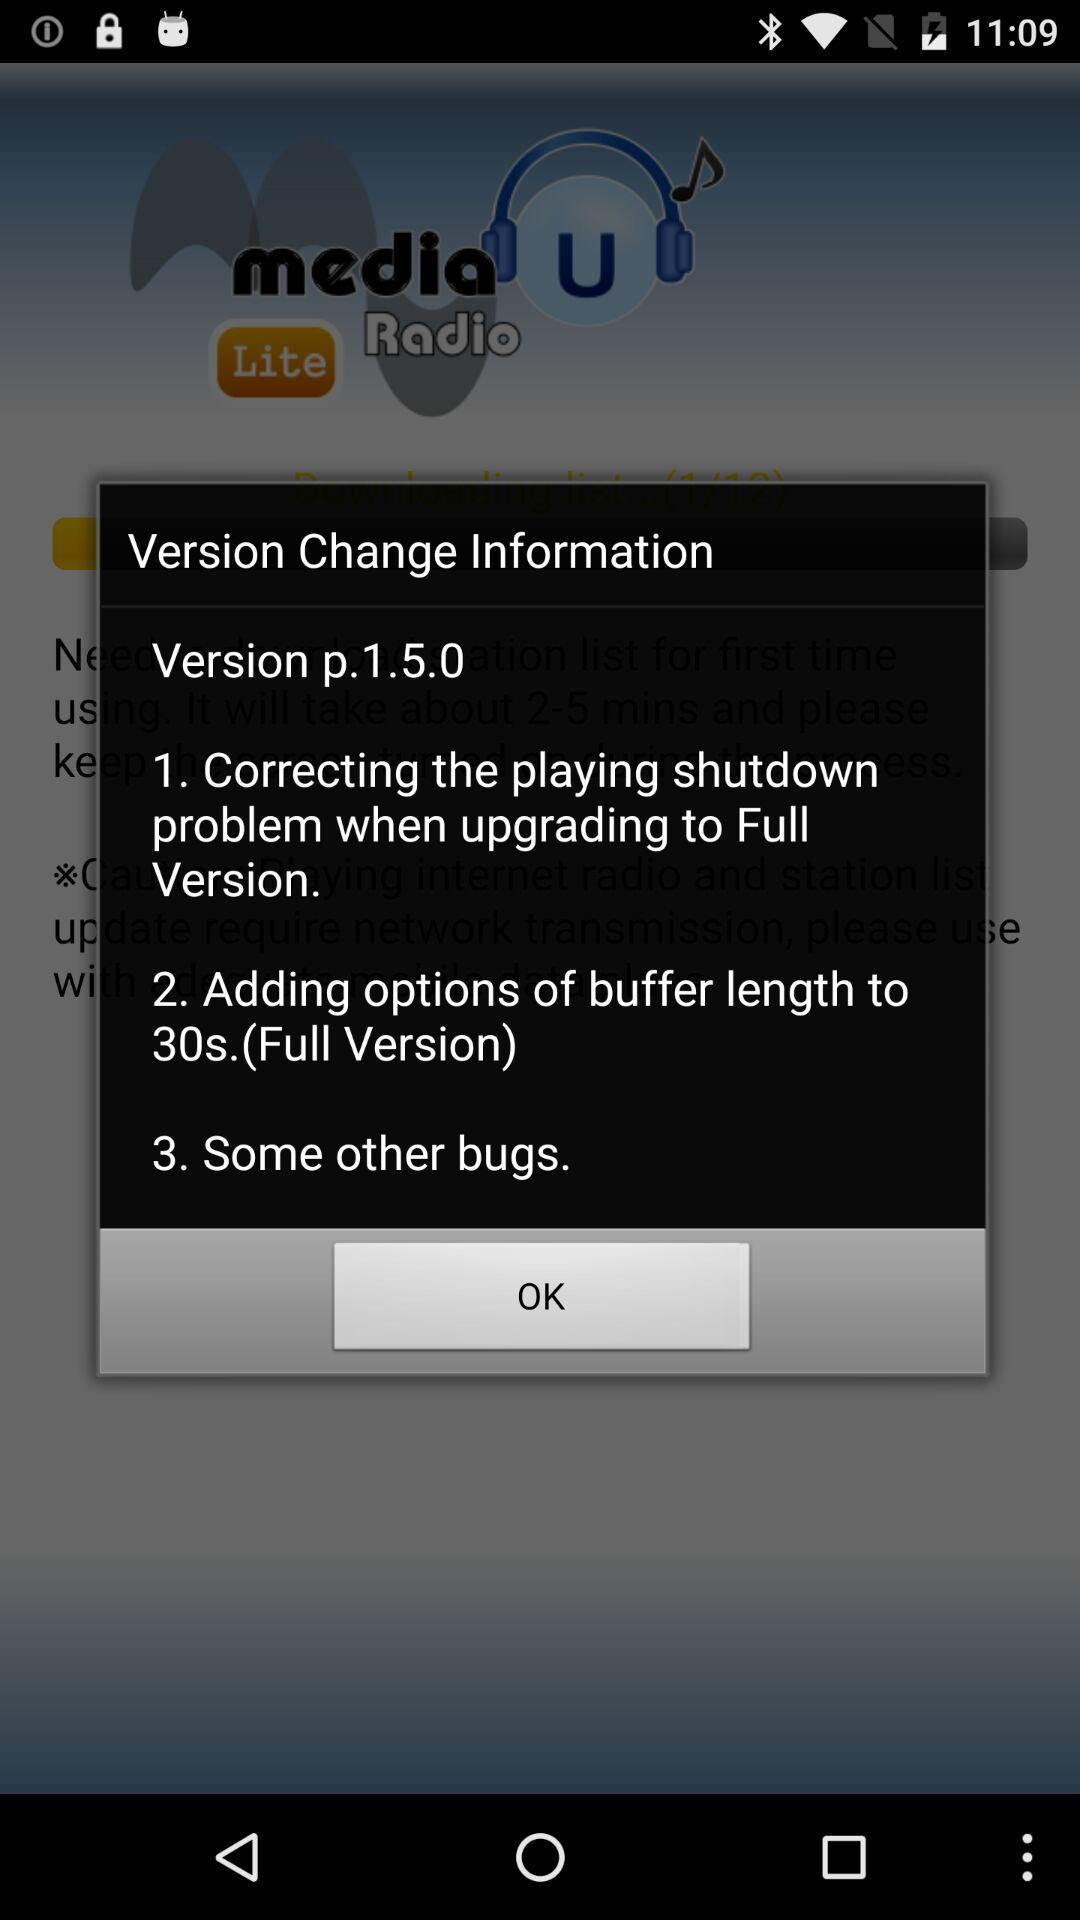How many bugs have been fixed?
Answer the question using a single word or phrase. 3 